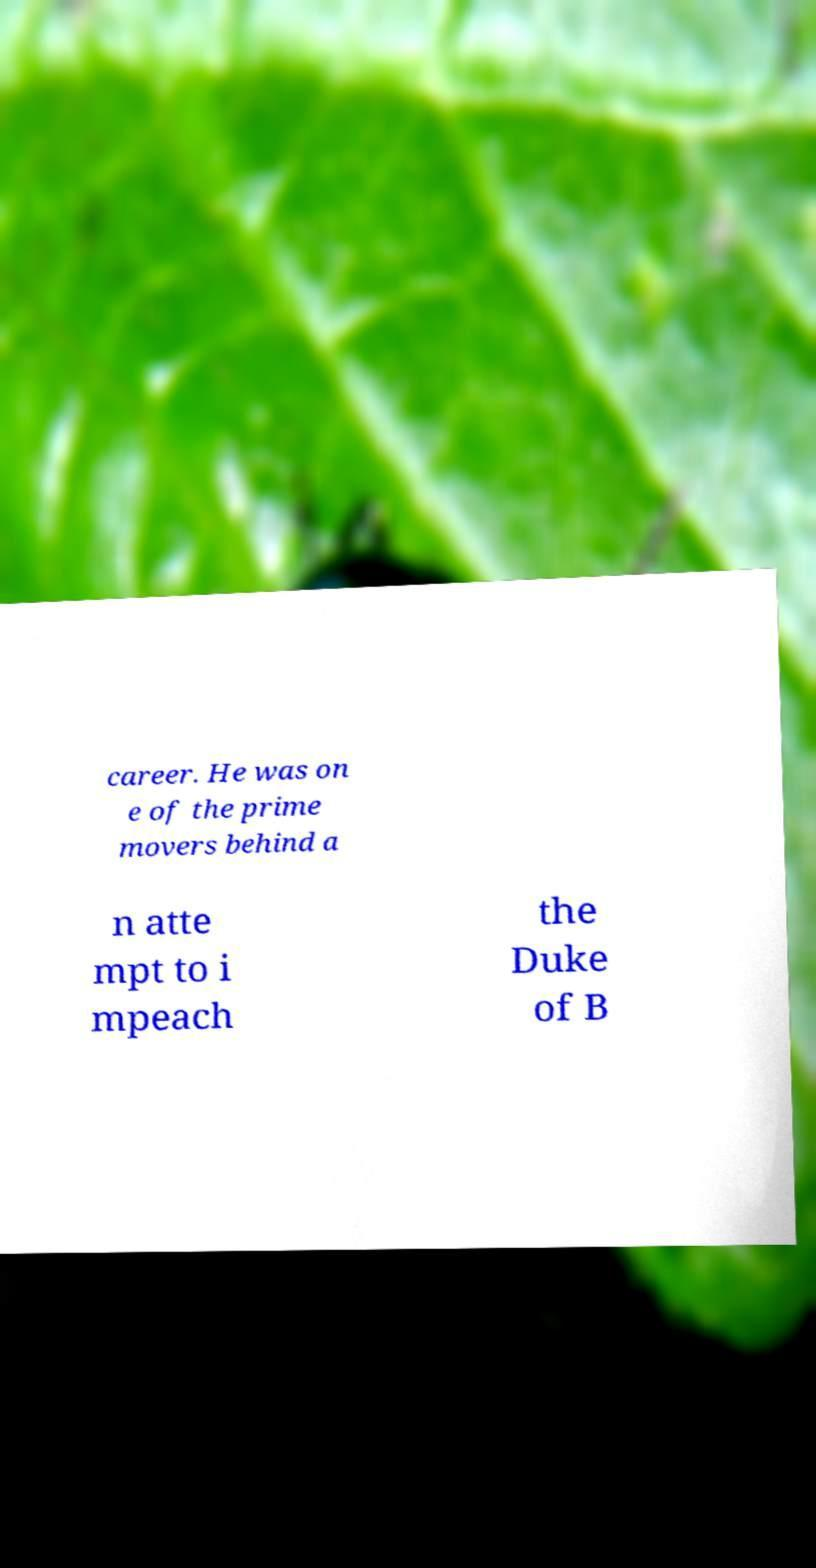I need the written content from this picture converted into text. Can you do that? career. He was on e of the prime movers behind a n atte mpt to i mpeach the Duke of B 